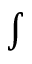<formula> <loc_0><loc_0><loc_500><loc_500>\int</formula> 